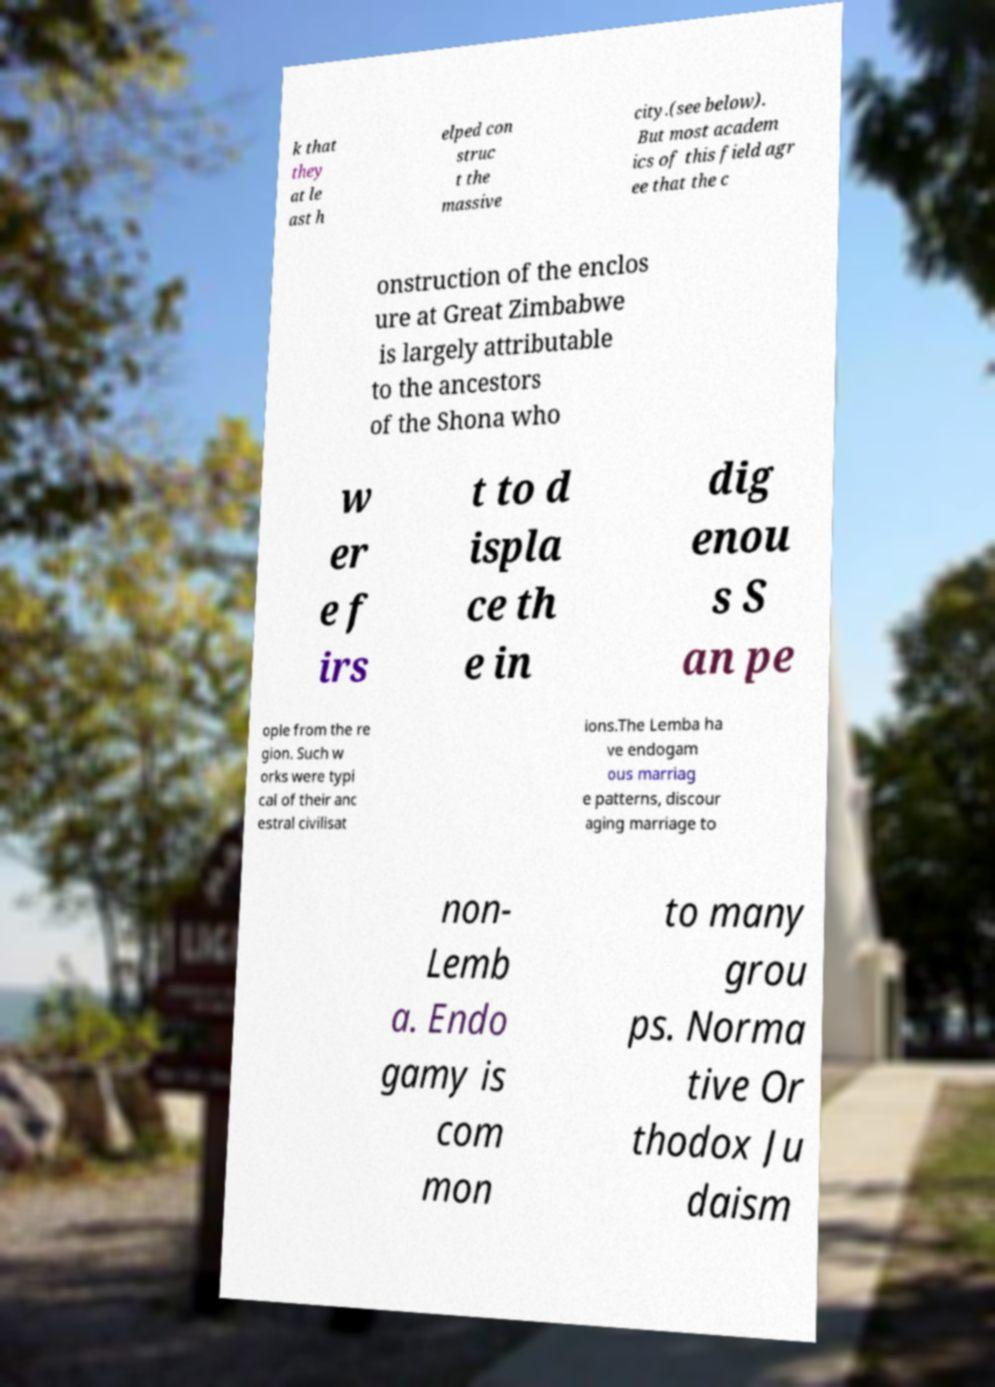What messages or text are displayed in this image? I need them in a readable, typed format. k that they at le ast h elped con struc t the massive city.(see below). But most academ ics of this field agr ee that the c onstruction of the enclos ure at Great Zimbabwe is largely attributable to the ancestors of the Shona who w er e f irs t to d ispla ce th e in dig enou s S an pe ople from the re gion. Such w orks were typi cal of their anc estral civilisat ions.The Lemba ha ve endogam ous marriag e patterns, discour aging marriage to non- Lemb a. Endo gamy is com mon to many grou ps. Norma tive Or thodox Ju daism 